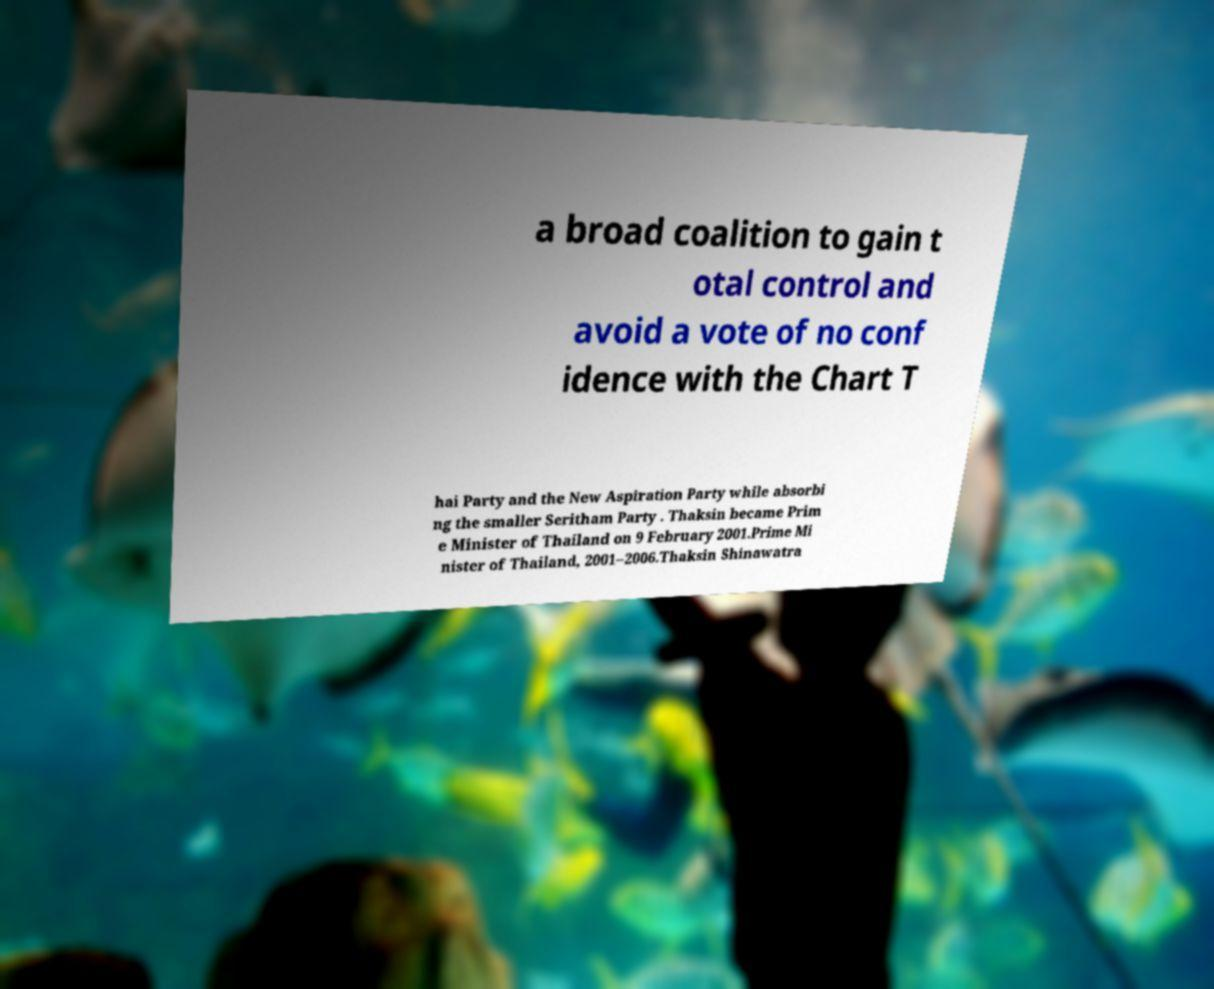I need the written content from this picture converted into text. Can you do that? a broad coalition to gain t otal control and avoid a vote of no conf idence with the Chart T hai Party and the New Aspiration Party while absorbi ng the smaller Seritham Party . Thaksin became Prim e Minister of Thailand on 9 February 2001.Prime Mi nister of Thailand, 2001–2006.Thaksin Shinawatra 